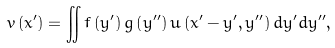<formula> <loc_0><loc_0><loc_500><loc_500>v \left ( x ^ { \prime } \right ) = \iint f \left ( y ^ { \prime } \right ) g \left ( y ^ { \prime \prime } \right ) u \left ( x ^ { \prime } - y ^ { \prime } , y ^ { \prime \prime } \right ) d y ^ { \prime } d y ^ { \prime \prime } ,</formula> 